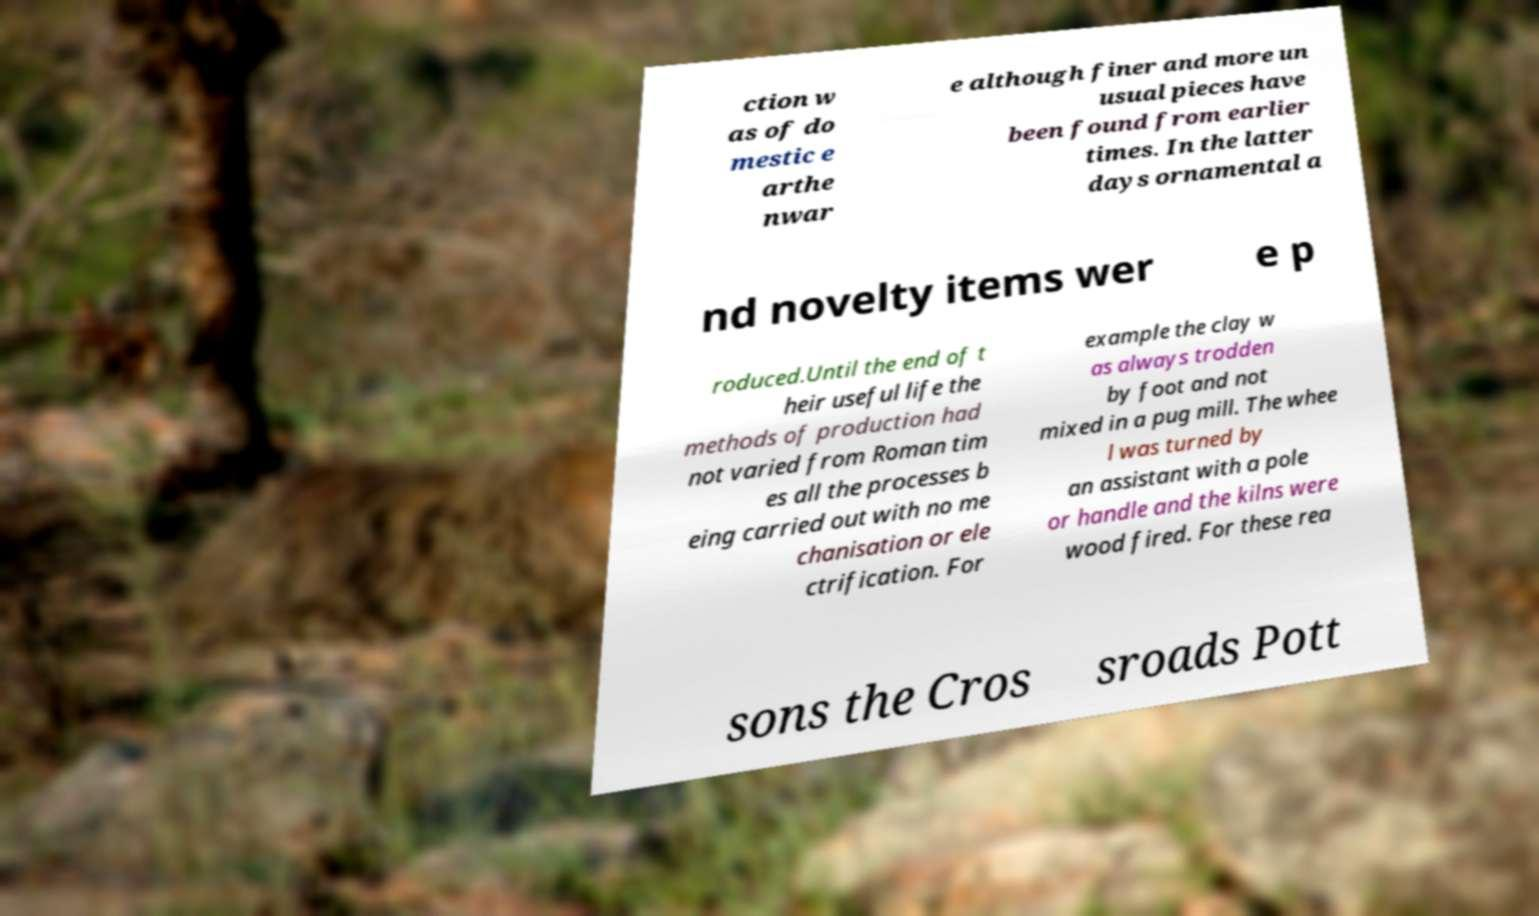There's text embedded in this image that I need extracted. Can you transcribe it verbatim? ction w as of do mestic e arthe nwar e although finer and more un usual pieces have been found from earlier times. In the latter days ornamental a nd novelty items wer e p roduced.Until the end of t heir useful life the methods of production had not varied from Roman tim es all the processes b eing carried out with no me chanisation or ele ctrification. For example the clay w as always trodden by foot and not mixed in a pug mill. The whee l was turned by an assistant with a pole or handle and the kilns were wood fired. For these rea sons the Cros sroads Pott 